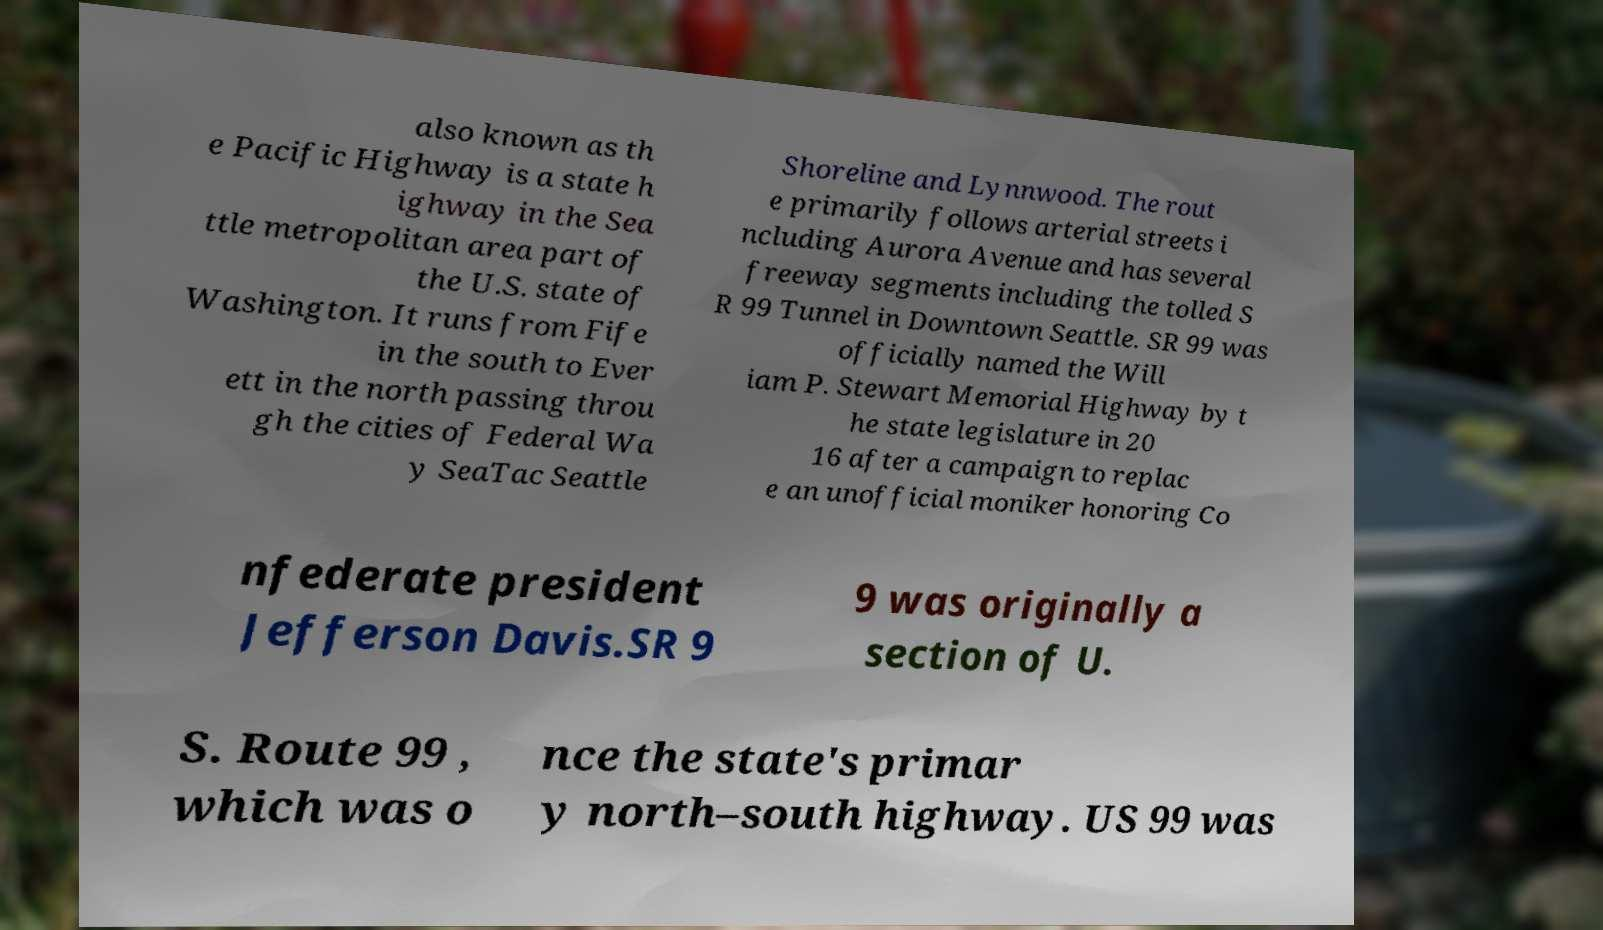There's text embedded in this image that I need extracted. Can you transcribe it verbatim? also known as th e Pacific Highway is a state h ighway in the Sea ttle metropolitan area part of the U.S. state of Washington. It runs from Fife in the south to Ever ett in the north passing throu gh the cities of Federal Wa y SeaTac Seattle Shoreline and Lynnwood. The rout e primarily follows arterial streets i ncluding Aurora Avenue and has several freeway segments including the tolled S R 99 Tunnel in Downtown Seattle. SR 99 was officially named the Will iam P. Stewart Memorial Highway by t he state legislature in 20 16 after a campaign to replac e an unofficial moniker honoring Co nfederate president Jefferson Davis.SR 9 9 was originally a section of U. S. Route 99 , which was o nce the state's primar y north–south highway. US 99 was 